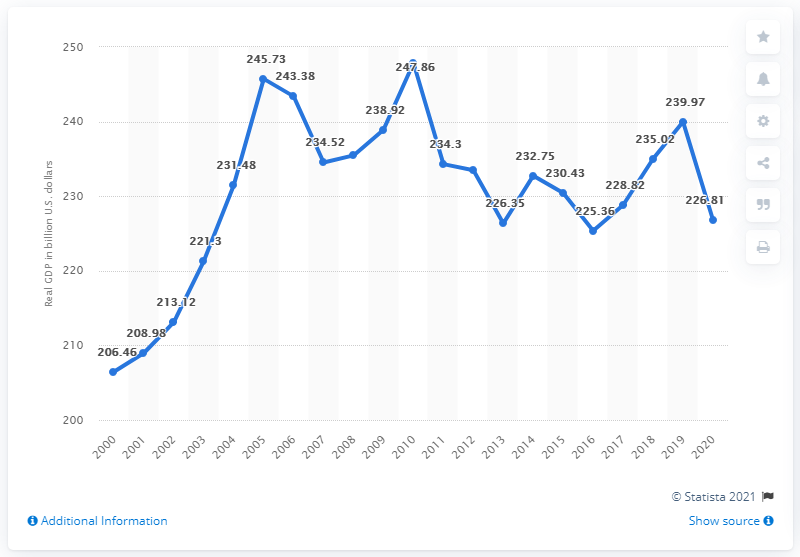Specify some key components in this picture. In 2020, Louisiana's Gross Domestic Product (GDP) was estimated to be 226.81 billion dollars. 